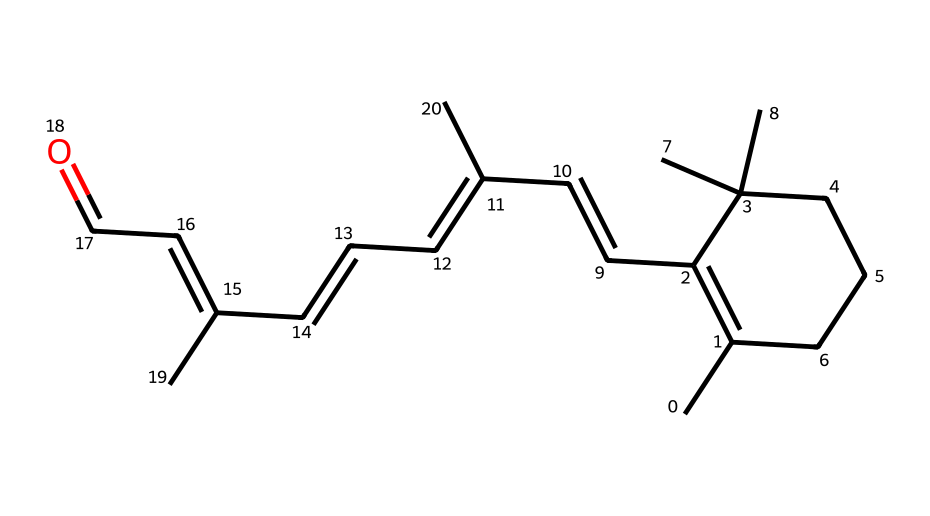What is the molecular formula of this chemical? To determine the molecular formula, we need to count all the carbon (C) and hydrogen (H) atoms present in the structure. By analyzing the SMILES notation, we find that there are 20 carbon atoms and 30 hydrogen atoms. Therefore, the molecular formula is C20H30.
Answer: C20H30 How many double bonds are present in the molecule? By inspecting the chemical structure, we can identify the locations of double bonds, which is typically represented by '=' in the SMILES. In this structure, there are 5 double bonds present.
Answer: 5 What functional groups can be identified in this hydrocarbon? Examining the chemical structure, we look for functional groups. The presence of a carbonyl group (C=O) indicates it belongs to a ketone functional group, in this case. Therefore, the primary functional group in this hydrocarbon is a ketone.
Answer: ketone What is the degree of saturation in this chemical? The degree of saturation can be calculated using the formula (number of hydrogens + 2 - (number of carbons)) / 2. Here, substituting in the values gives us (30 + 2 - 20) / 2 = 6. This indicates the degree of saturation, reflecting the level of saturation in the hydrocarbon chain.
Answer: 6 What type of isomerism is exhibited in this compound? The compound exhibits geometric isomerism due to the presence of multiple double bonds, which can create different arrangements of the substituents in the structure. This is a common characteristic in compounds containing double bonds.
Answer: geometric isomerism What type of hydrocarbon structure does retinol represent? Since retinol has a carbon framework mostly consisting of single and double bonds, it forms an acyclic structure with multiple carbon chains rather than a cyclic structure. Therefore, it is identified as an acyclic hydrocarbon.
Answer: acyclic hydrocarbon 